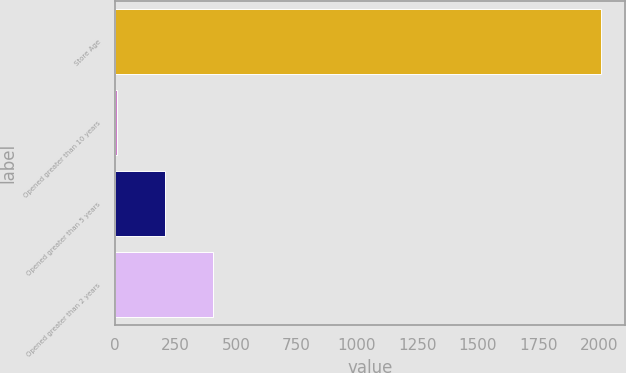Convert chart. <chart><loc_0><loc_0><loc_500><loc_500><bar_chart><fcel>Store Age<fcel>Opened greater than 10 years<fcel>Opened greater than 5 years<fcel>Opened greater than 2 years<nl><fcel>2008<fcel>6.9<fcel>207.01<fcel>407.12<nl></chart> 